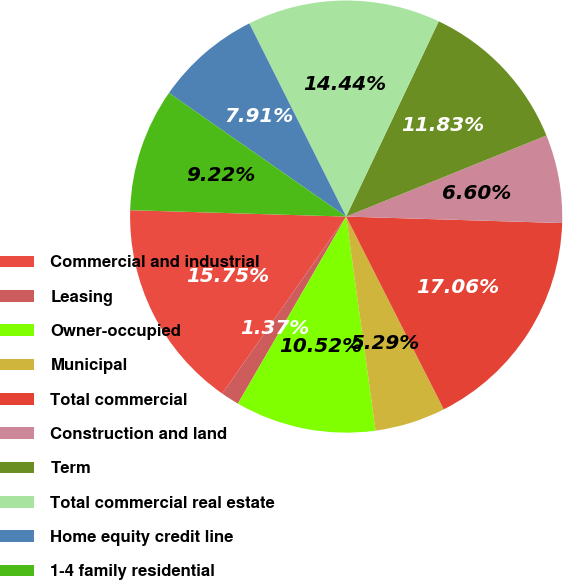Convert chart to OTSL. <chart><loc_0><loc_0><loc_500><loc_500><pie_chart><fcel>Commercial and industrial<fcel>Leasing<fcel>Owner-occupied<fcel>Municipal<fcel>Total commercial<fcel>Construction and land<fcel>Term<fcel>Total commercial real estate<fcel>Home equity credit line<fcel>1-4 family residential<nl><fcel>15.75%<fcel>1.37%<fcel>10.52%<fcel>5.29%<fcel>17.06%<fcel>6.6%<fcel>11.83%<fcel>14.44%<fcel>7.91%<fcel>9.22%<nl></chart> 